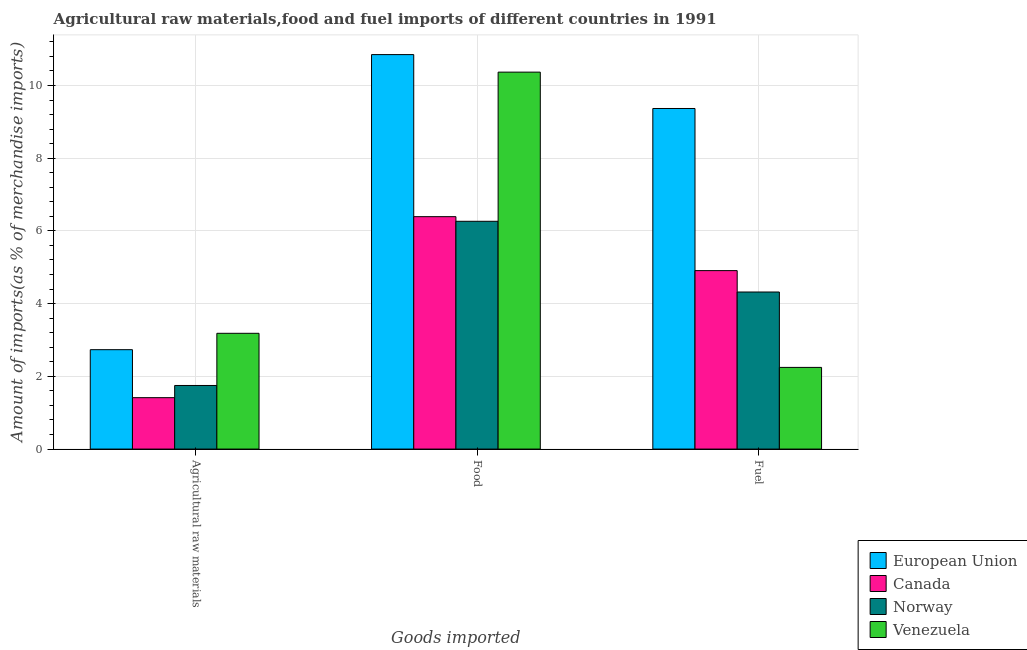How many groups of bars are there?
Your answer should be very brief. 3. How many bars are there on the 2nd tick from the right?
Your response must be concise. 4. What is the label of the 2nd group of bars from the left?
Your answer should be compact. Food. What is the percentage of raw materials imports in Norway?
Your answer should be very brief. 1.75. Across all countries, what is the maximum percentage of fuel imports?
Keep it short and to the point. 9.37. Across all countries, what is the minimum percentage of raw materials imports?
Make the answer very short. 1.41. In which country was the percentage of food imports maximum?
Keep it short and to the point. European Union. What is the total percentage of fuel imports in the graph?
Your answer should be very brief. 20.84. What is the difference between the percentage of fuel imports in Venezuela and that in European Union?
Give a very brief answer. -7.12. What is the difference between the percentage of fuel imports in Norway and the percentage of food imports in Canada?
Offer a terse response. -2.07. What is the average percentage of fuel imports per country?
Your answer should be compact. 5.21. What is the difference between the percentage of fuel imports and percentage of raw materials imports in Venezuela?
Offer a terse response. -0.94. In how many countries, is the percentage of food imports greater than 7.6 %?
Ensure brevity in your answer.  2. What is the ratio of the percentage of fuel imports in Canada to that in Venezuela?
Keep it short and to the point. 2.18. Is the percentage of fuel imports in European Union less than that in Venezuela?
Offer a very short reply. No. Is the difference between the percentage of raw materials imports in Norway and Canada greater than the difference between the percentage of fuel imports in Norway and Canada?
Offer a terse response. Yes. What is the difference between the highest and the second highest percentage of food imports?
Your answer should be very brief. 0.48. What is the difference between the highest and the lowest percentage of fuel imports?
Provide a short and direct response. 7.12. How many bars are there?
Make the answer very short. 12. What is the difference between two consecutive major ticks on the Y-axis?
Offer a very short reply. 2. Are the values on the major ticks of Y-axis written in scientific E-notation?
Your answer should be very brief. No. Does the graph contain any zero values?
Provide a short and direct response. No. What is the title of the graph?
Provide a short and direct response. Agricultural raw materials,food and fuel imports of different countries in 1991. What is the label or title of the X-axis?
Provide a succinct answer. Goods imported. What is the label or title of the Y-axis?
Give a very brief answer. Amount of imports(as % of merchandise imports). What is the Amount of imports(as % of merchandise imports) in European Union in Agricultural raw materials?
Your answer should be very brief. 2.73. What is the Amount of imports(as % of merchandise imports) in Canada in Agricultural raw materials?
Your answer should be very brief. 1.41. What is the Amount of imports(as % of merchandise imports) in Norway in Agricultural raw materials?
Keep it short and to the point. 1.75. What is the Amount of imports(as % of merchandise imports) in Venezuela in Agricultural raw materials?
Ensure brevity in your answer.  3.18. What is the Amount of imports(as % of merchandise imports) of European Union in Food?
Your response must be concise. 10.85. What is the Amount of imports(as % of merchandise imports) of Canada in Food?
Ensure brevity in your answer.  6.39. What is the Amount of imports(as % of merchandise imports) in Norway in Food?
Provide a short and direct response. 6.26. What is the Amount of imports(as % of merchandise imports) in Venezuela in Food?
Provide a succinct answer. 10.37. What is the Amount of imports(as % of merchandise imports) in European Union in Fuel?
Ensure brevity in your answer.  9.37. What is the Amount of imports(as % of merchandise imports) of Canada in Fuel?
Give a very brief answer. 4.91. What is the Amount of imports(as % of merchandise imports) in Norway in Fuel?
Your answer should be compact. 4.32. What is the Amount of imports(as % of merchandise imports) in Venezuela in Fuel?
Give a very brief answer. 2.25. Across all Goods imported, what is the maximum Amount of imports(as % of merchandise imports) of European Union?
Provide a succinct answer. 10.85. Across all Goods imported, what is the maximum Amount of imports(as % of merchandise imports) of Canada?
Keep it short and to the point. 6.39. Across all Goods imported, what is the maximum Amount of imports(as % of merchandise imports) of Norway?
Make the answer very short. 6.26. Across all Goods imported, what is the maximum Amount of imports(as % of merchandise imports) of Venezuela?
Provide a succinct answer. 10.37. Across all Goods imported, what is the minimum Amount of imports(as % of merchandise imports) in European Union?
Ensure brevity in your answer.  2.73. Across all Goods imported, what is the minimum Amount of imports(as % of merchandise imports) in Canada?
Your answer should be very brief. 1.41. Across all Goods imported, what is the minimum Amount of imports(as % of merchandise imports) of Norway?
Make the answer very short. 1.75. Across all Goods imported, what is the minimum Amount of imports(as % of merchandise imports) of Venezuela?
Your answer should be very brief. 2.25. What is the total Amount of imports(as % of merchandise imports) of European Union in the graph?
Your answer should be compact. 22.95. What is the total Amount of imports(as % of merchandise imports) of Canada in the graph?
Your answer should be compact. 12.71. What is the total Amount of imports(as % of merchandise imports) of Norway in the graph?
Your answer should be compact. 12.33. What is the total Amount of imports(as % of merchandise imports) of Venezuela in the graph?
Make the answer very short. 15.8. What is the difference between the Amount of imports(as % of merchandise imports) in European Union in Agricultural raw materials and that in Food?
Keep it short and to the point. -8.12. What is the difference between the Amount of imports(as % of merchandise imports) in Canada in Agricultural raw materials and that in Food?
Offer a terse response. -4.98. What is the difference between the Amount of imports(as % of merchandise imports) in Norway in Agricultural raw materials and that in Food?
Offer a very short reply. -4.52. What is the difference between the Amount of imports(as % of merchandise imports) of Venezuela in Agricultural raw materials and that in Food?
Provide a short and direct response. -7.18. What is the difference between the Amount of imports(as % of merchandise imports) in European Union in Agricultural raw materials and that in Fuel?
Provide a short and direct response. -6.63. What is the difference between the Amount of imports(as % of merchandise imports) of Canada in Agricultural raw materials and that in Fuel?
Provide a short and direct response. -3.49. What is the difference between the Amount of imports(as % of merchandise imports) in Norway in Agricultural raw materials and that in Fuel?
Ensure brevity in your answer.  -2.57. What is the difference between the Amount of imports(as % of merchandise imports) of European Union in Food and that in Fuel?
Keep it short and to the point. 1.48. What is the difference between the Amount of imports(as % of merchandise imports) in Canada in Food and that in Fuel?
Your response must be concise. 1.48. What is the difference between the Amount of imports(as % of merchandise imports) in Norway in Food and that in Fuel?
Offer a terse response. 1.94. What is the difference between the Amount of imports(as % of merchandise imports) of Venezuela in Food and that in Fuel?
Offer a very short reply. 8.12. What is the difference between the Amount of imports(as % of merchandise imports) of European Union in Agricultural raw materials and the Amount of imports(as % of merchandise imports) of Canada in Food?
Offer a very short reply. -3.66. What is the difference between the Amount of imports(as % of merchandise imports) of European Union in Agricultural raw materials and the Amount of imports(as % of merchandise imports) of Norway in Food?
Make the answer very short. -3.53. What is the difference between the Amount of imports(as % of merchandise imports) of European Union in Agricultural raw materials and the Amount of imports(as % of merchandise imports) of Venezuela in Food?
Offer a very short reply. -7.63. What is the difference between the Amount of imports(as % of merchandise imports) of Canada in Agricultural raw materials and the Amount of imports(as % of merchandise imports) of Norway in Food?
Provide a short and direct response. -4.85. What is the difference between the Amount of imports(as % of merchandise imports) of Canada in Agricultural raw materials and the Amount of imports(as % of merchandise imports) of Venezuela in Food?
Your answer should be very brief. -8.95. What is the difference between the Amount of imports(as % of merchandise imports) of Norway in Agricultural raw materials and the Amount of imports(as % of merchandise imports) of Venezuela in Food?
Provide a succinct answer. -8.62. What is the difference between the Amount of imports(as % of merchandise imports) of European Union in Agricultural raw materials and the Amount of imports(as % of merchandise imports) of Canada in Fuel?
Give a very brief answer. -2.17. What is the difference between the Amount of imports(as % of merchandise imports) in European Union in Agricultural raw materials and the Amount of imports(as % of merchandise imports) in Norway in Fuel?
Provide a succinct answer. -1.59. What is the difference between the Amount of imports(as % of merchandise imports) of European Union in Agricultural raw materials and the Amount of imports(as % of merchandise imports) of Venezuela in Fuel?
Offer a very short reply. 0.49. What is the difference between the Amount of imports(as % of merchandise imports) in Canada in Agricultural raw materials and the Amount of imports(as % of merchandise imports) in Norway in Fuel?
Provide a succinct answer. -2.91. What is the difference between the Amount of imports(as % of merchandise imports) of Canada in Agricultural raw materials and the Amount of imports(as % of merchandise imports) of Venezuela in Fuel?
Your answer should be very brief. -0.83. What is the difference between the Amount of imports(as % of merchandise imports) in Norway in Agricultural raw materials and the Amount of imports(as % of merchandise imports) in Venezuela in Fuel?
Ensure brevity in your answer.  -0.5. What is the difference between the Amount of imports(as % of merchandise imports) of European Union in Food and the Amount of imports(as % of merchandise imports) of Canada in Fuel?
Your answer should be very brief. 5.94. What is the difference between the Amount of imports(as % of merchandise imports) in European Union in Food and the Amount of imports(as % of merchandise imports) in Norway in Fuel?
Your answer should be compact. 6.53. What is the difference between the Amount of imports(as % of merchandise imports) in European Union in Food and the Amount of imports(as % of merchandise imports) in Venezuela in Fuel?
Your answer should be very brief. 8.6. What is the difference between the Amount of imports(as % of merchandise imports) in Canada in Food and the Amount of imports(as % of merchandise imports) in Norway in Fuel?
Keep it short and to the point. 2.07. What is the difference between the Amount of imports(as % of merchandise imports) in Canada in Food and the Amount of imports(as % of merchandise imports) in Venezuela in Fuel?
Your answer should be very brief. 4.15. What is the difference between the Amount of imports(as % of merchandise imports) in Norway in Food and the Amount of imports(as % of merchandise imports) in Venezuela in Fuel?
Ensure brevity in your answer.  4.02. What is the average Amount of imports(as % of merchandise imports) in European Union per Goods imported?
Make the answer very short. 7.65. What is the average Amount of imports(as % of merchandise imports) of Canada per Goods imported?
Offer a terse response. 4.24. What is the average Amount of imports(as % of merchandise imports) in Norway per Goods imported?
Provide a short and direct response. 4.11. What is the average Amount of imports(as % of merchandise imports) of Venezuela per Goods imported?
Keep it short and to the point. 5.27. What is the difference between the Amount of imports(as % of merchandise imports) in European Union and Amount of imports(as % of merchandise imports) in Canada in Agricultural raw materials?
Offer a very short reply. 1.32. What is the difference between the Amount of imports(as % of merchandise imports) in European Union and Amount of imports(as % of merchandise imports) in Norway in Agricultural raw materials?
Provide a short and direct response. 0.98. What is the difference between the Amount of imports(as % of merchandise imports) of European Union and Amount of imports(as % of merchandise imports) of Venezuela in Agricultural raw materials?
Your answer should be compact. -0.45. What is the difference between the Amount of imports(as % of merchandise imports) in Canada and Amount of imports(as % of merchandise imports) in Norway in Agricultural raw materials?
Your answer should be compact. -0.34. What is the difference between the Amount of imports(as % of merchandise imports) of Canada and Amount of imports(as % of merchandise imports) of Venezuela in Agricultural raw materials?
Keep it short and to the point. -1.77. What is the difference between the Amount of imports(as % of merchandise imports) in Norway and Amount of imports(as % of merchandise imports) in Venezuela in Agricultural raw materials?
Give a very brief answer. -1.43. What is the difference between the Amount of imports(as % of merchandise imports) in European Union and Amount of imports(as % of merchandise imports) in Canada in Food?
Give a very brief answer. 4.46. What is the difference between the Amount of imports(as % of merchandise imports) of European Union and Amount of imports(as % of merchandise imports) of Norway in Food?
Your answer should be very brief. 4.58. What is the difference between the Amount of imports(as % of merchandise imports) of European Union and Amount of imports(as % of merchandise imports) of Venezuela in Food?
Offer a terse response. 0.48. What is the difference between the Amount of imports(as % of merchandise imports) of Canada and Amount of imports(as % of merchandise imports) of Norway in Food?
Give a very brief answer. 0.13. What is the difference between the Amount of imports(as % of merchandise imports) in Canada and Amount of imports(as % of merchandise imports) in Venezuela in Food?
Make the answer very short. -3.97. What is the difference between the Amount of imports(as % of merchandise imports) of Norway and Amount of imports(as % of merchandise imports) of Venezuela in Food?
Your answer should be very brief. -4.1. What is the difference between the Amount of imports(as % of merchandise imports) in European Union and Amount of imports(as % of merchandise imports) in Canada in Fuel?
Ensure brevity in your answer.  4.46. What is the difference between the Amount of imports(as % of merchandise imports) of European Union and Amount of imports(as % of merchandise imports) of Norway in Fuel?
Give a very brief answer. 5.05. What is the difference between the Amount of imports(as % of merchandise imports) of European Union and Amount of imports(as % of merchandise imports) of Venezuela in Fuel?
Your answer should be very brief. 7.12. What is the difference between the Amount of imports(as % of merchandise imports) in Canada and Amount of imports(as % of merchandise imports) in Norway in Fuel?
Keep it short and to the point. 0.59. What is the difference between the Amount of imports(as % of merchandise imports) in Canada and Amount of imports(as % of merchandise imports) in Venezuela in Fuel?
Offer a very short reply. 2.66. What is the difference between the Amount of imports(as % of merchandise imports) in Norway and Amount of imports(as % of merchandise imports) in Venezuela in Fuel?
Your response must be concise. 2.07. What is the ratio of the Amount of imports(as % of merchandise imports) of European Union in Agricultural raw materials to that in Food?
Keep it short and to the point. 0.25. What is the ratio of the Amount of imports(as % of merchandise imports) in Canada in Agricultural raw materials to that in Food?
Offer a terse response. 0.22. What is the ratio of the Amount of imports(as % of merchandise imports) of Norway in Agricultural raw materials to that in Food?
Provide a short and direct response. 0.28. What is the ratio of the Amount of imports(as % of merchandise imports) of Venezuela in Agricultural raw materials to that in Food?
Keep it short and to the point. 0.31. What is the ratio of the Amount of imports(as % of merchandise imports) of European Union in Agricultural raw materials to that in Fuel?
Keep it short and to the point. 0.29. What is the ratio of the Amount of imports(as % of merchandise imports) in Canada in Agricultural raw materials to that in Fuel?
Your answer should be compact. 0.29. What is the ratio of the Amount of imports(as % of merchandise imports) in Norway in Agricultural raw materials to that in Fuel?
Make the answer very short. 0.4. What is the ratio of the Amount of imports(as % of merchandise imports) in Venezuela in Agricultural raw materials to that in Fuel?
Give a very brief answer. 1.42. What is the ratio of the Amount of imports(as % of merchandise imports) of European Union in Food to that in Fuel?
Provide a succinct answer. 1.16. What is the ratio of the Amount of imports(as % of merchandise imports) in Canada in Food to that in Fuel?
Your answer should be very brief. 1.3. What is the ratio of the Amount of imports(as % of merchandise imports) of Norway in Food to that in Fuel?
Keep it short and to the point. 1.45. What is the ratio of the Amount of imports(as % of merchandise imports) in Venezuela in Food to that in Fuel?
Offer a terse response. 4.61. What is the difference between the highest and the second highest Amount of imports(as % of merchandise imports) of European Union?
Provide a short and direct response. 1.48. What is the difference between the highest and the second highest Amount of imports(as % of merchandise imports) of Canada?
Offer a very short reply. 1.48. What is the difference between the highest and the second highest Amount of imports(as % of merchandise imports) of Norway?
Your response must be concise. 1.94. What is the difference between the highest and the second highest Amount of imports(as % of merchandise imports) in Venezuela?
Your answer should be compact. 7.18. What is the difference between the highest and the lowest Amount of imports(as % of merchandise imports) in European Union?
Keep it short and to the point. 8.12. What is the difference between the highest and the lowest Amount of imports(as % of merchandise imports) in Canada?
Provide a succinct answer. 4.98. What is the difference between the highest and the lowest Amount of imports(as % of merchandise imports) of Norway?
Offer a very short reply. 4.52. What is the difference between the highest and the lowest Amount of imports(as % of merchandise imports) in Venezuela?
Your response must be concise. 8.12. 